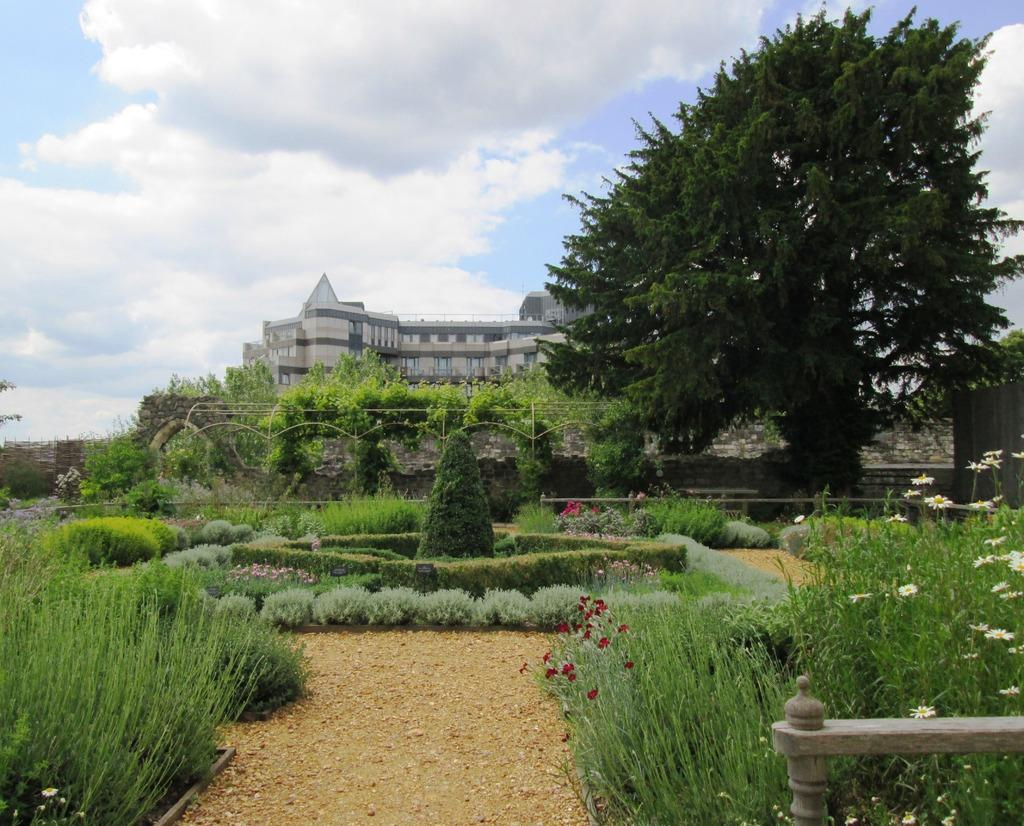What type of vegetation can be seen in the image? There is grass, shrubs, and trees in the image. What structures are present in the image? There is a fence, a stone wall, and a building in the image. What is visible in the background of the image? The sky is visible in the background of the image, with clouds present. What type of liquid is being poured from the plant in the image? There is no plant or liquid being poured in the image. Can you tell me how many stalks of celery are in the image? There is no celery present in the image. 